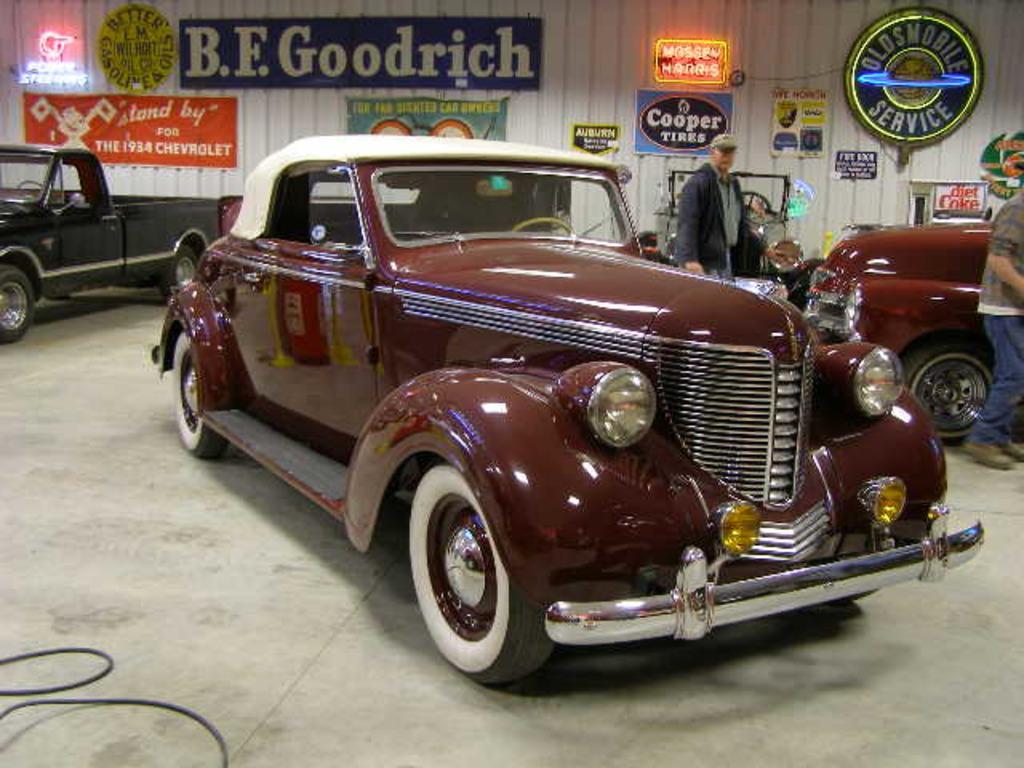Could you give a brief overview of what you see in this image? In this picture we can see people and vehicles on the ground and in the background we can see posters and some objects. 